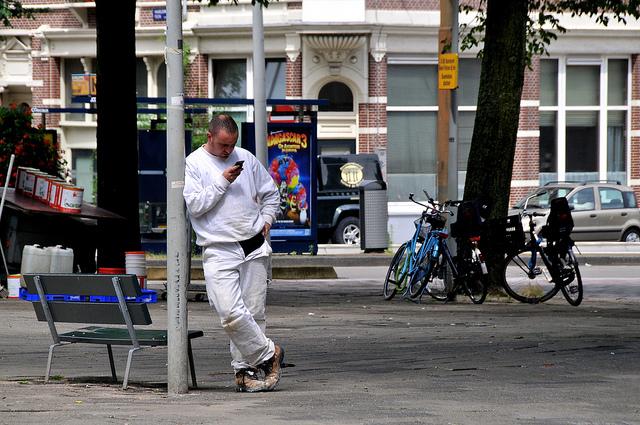Are the bikes secured with locks?
Be succinct. Yes. Is he carrying plastic bags?
Write a very short answer. No. What is the color of the man's clothes?
Give a very brief answer. White. Is this a real bike?
Concise answer only. Yes. What is the man carrying?
Keep it brief. Phone. Is anyone sitting on the bench?
Answer briefly. No. 